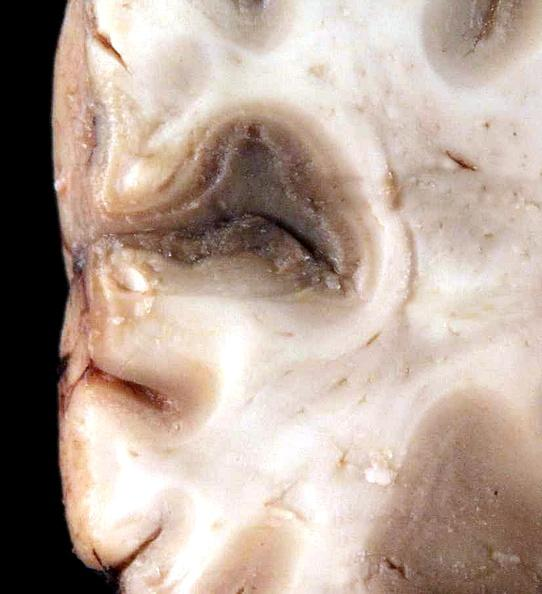what is present?
Answer the question using a single word or phrase. Nervous 